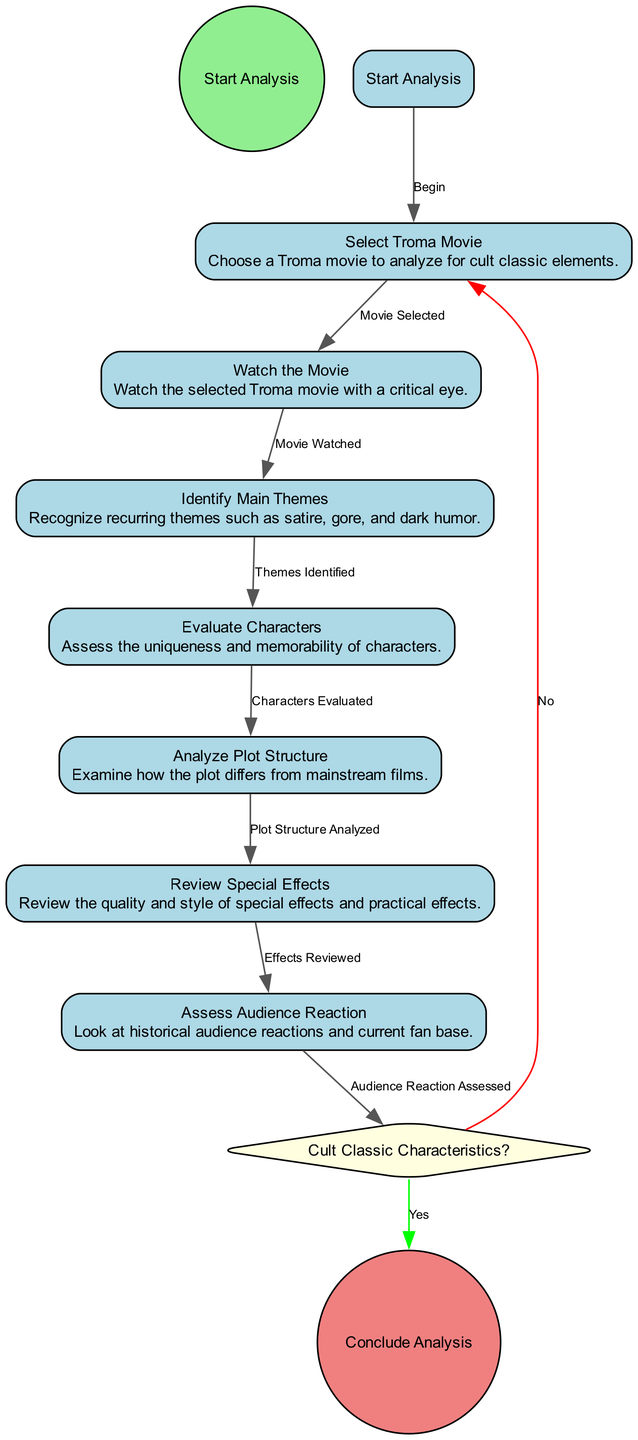What is the first activity in the diagram? The first activity is represented by the flow leading from the start event "Start Analysis" to "Select Troma Movie." Therefore, the first activity after starting the analysis is "Select Troma Movie."
Answer: Select Troma Movie How many activities are included in the diagram? The diagram shows a total of seven activities, as seen from the list presented after "Select Troma Movie" leading to the last activity "Assess Audience Reaction."
Answer: Seven What is the decision point in the diagram? The decision point is labeled "Cult Classic Characteristics?", which indicates it is a point where a choice must be made based on the characteristics of the movie being analyzed.
Answer: Cult Classic Characteristics? What follows the "Assess Audience Reaction" activity? The "Assess Audience Reaction" activity leads to the decision point "Cult Classic Characteristics?" as the next step according to the flow.
Answer: Cult Classic Characteristics? If the movie does not exhibit cult classic characteristics, which activity is next? If the decision is "No," the flow leads back to the "Select Troma Movie" activity, indicating that the analysis will start over with a new selection.
Answer: Select Troma Movie What type of node represents the conclusion of the analysis? The conclusion of the analysis is represented by a circle node labeled "Conclude Analysis," which indicates the endpoint of the activity flow.
Answer: Conclude Analysis Which activity involves reviewing the quality of effects? The activity that focuses on reviewing the quality and style of special effects is "Review Special Effects." This is one of the steps in the analysis process.
Answer: Review Special Effects What activity comes after "Analyze Plot Structure"? After "Analyze Plot Structure," the next step is "Review Special Effects," continuing the sequence of activities.
Answer: Review Special Effects How many edges connect the activities in the diagram? There are a total of eight edges connecting the activities, each indicating the flow from one step to the next in the analysis process.
Answer: Eight 